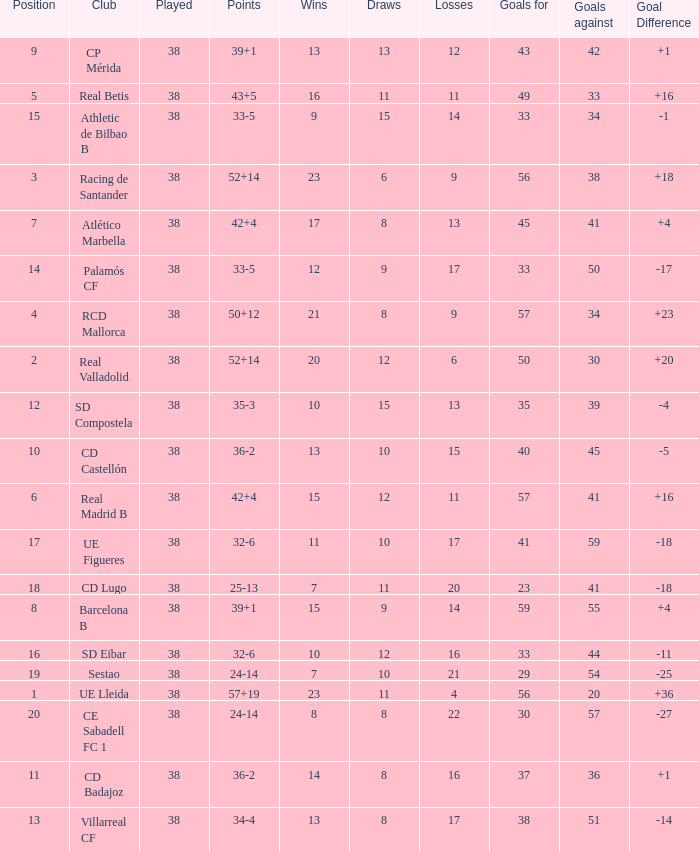What is the highest position with less than 17 losses, more than 57 goals, and a goal difference less than 4? None. 